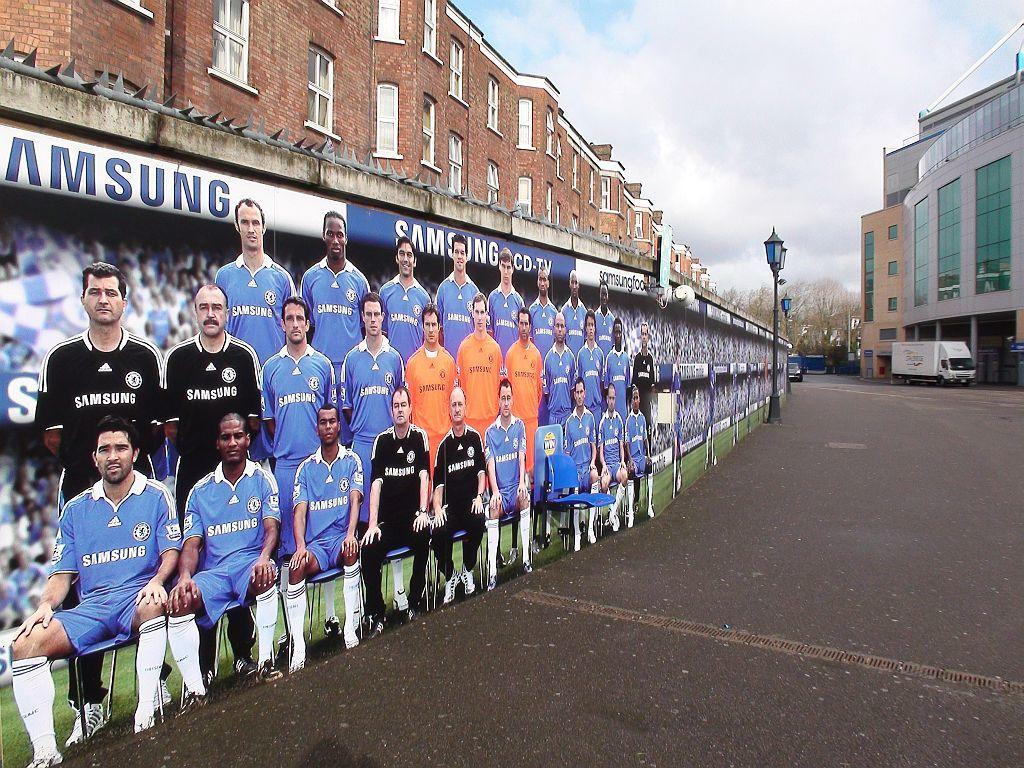<image>
Present a compact description of the photo's key features. A cardboard poster showing soccer players in blue Samsung jerseys. 